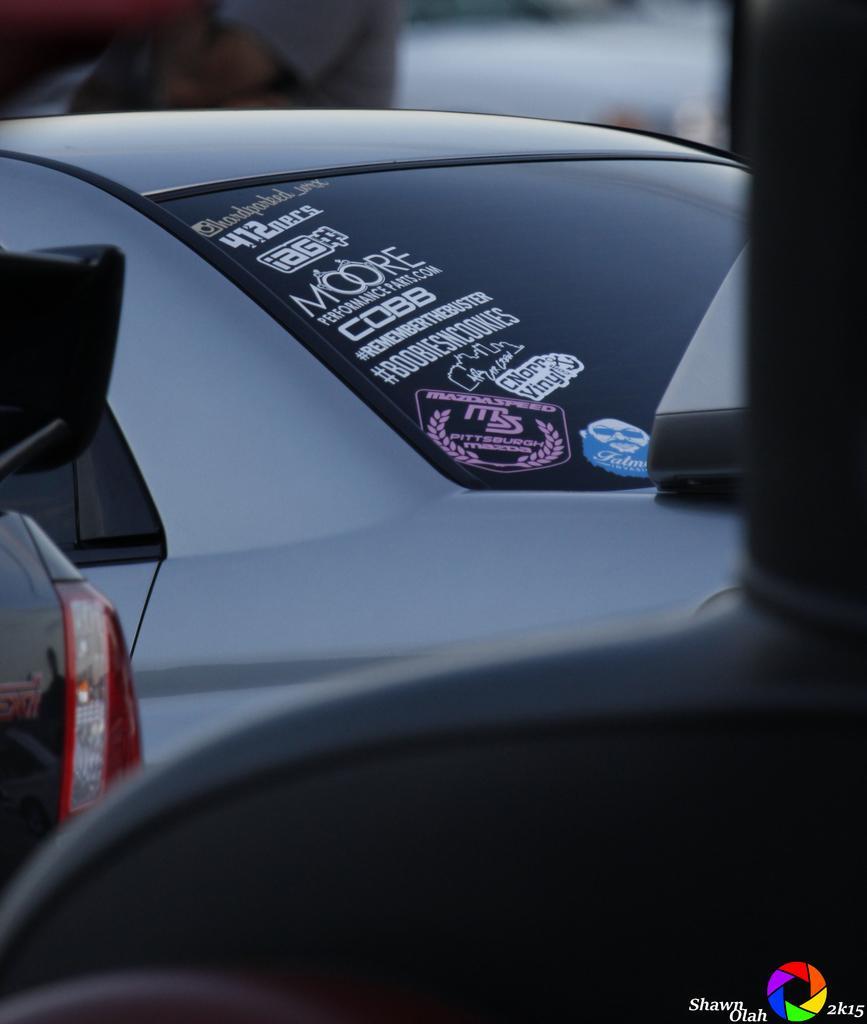Could you give a brief overview of what you see in this image? The picture is taken from a vehicle. In the center of the picture there are cars. At the top it is blurred. 